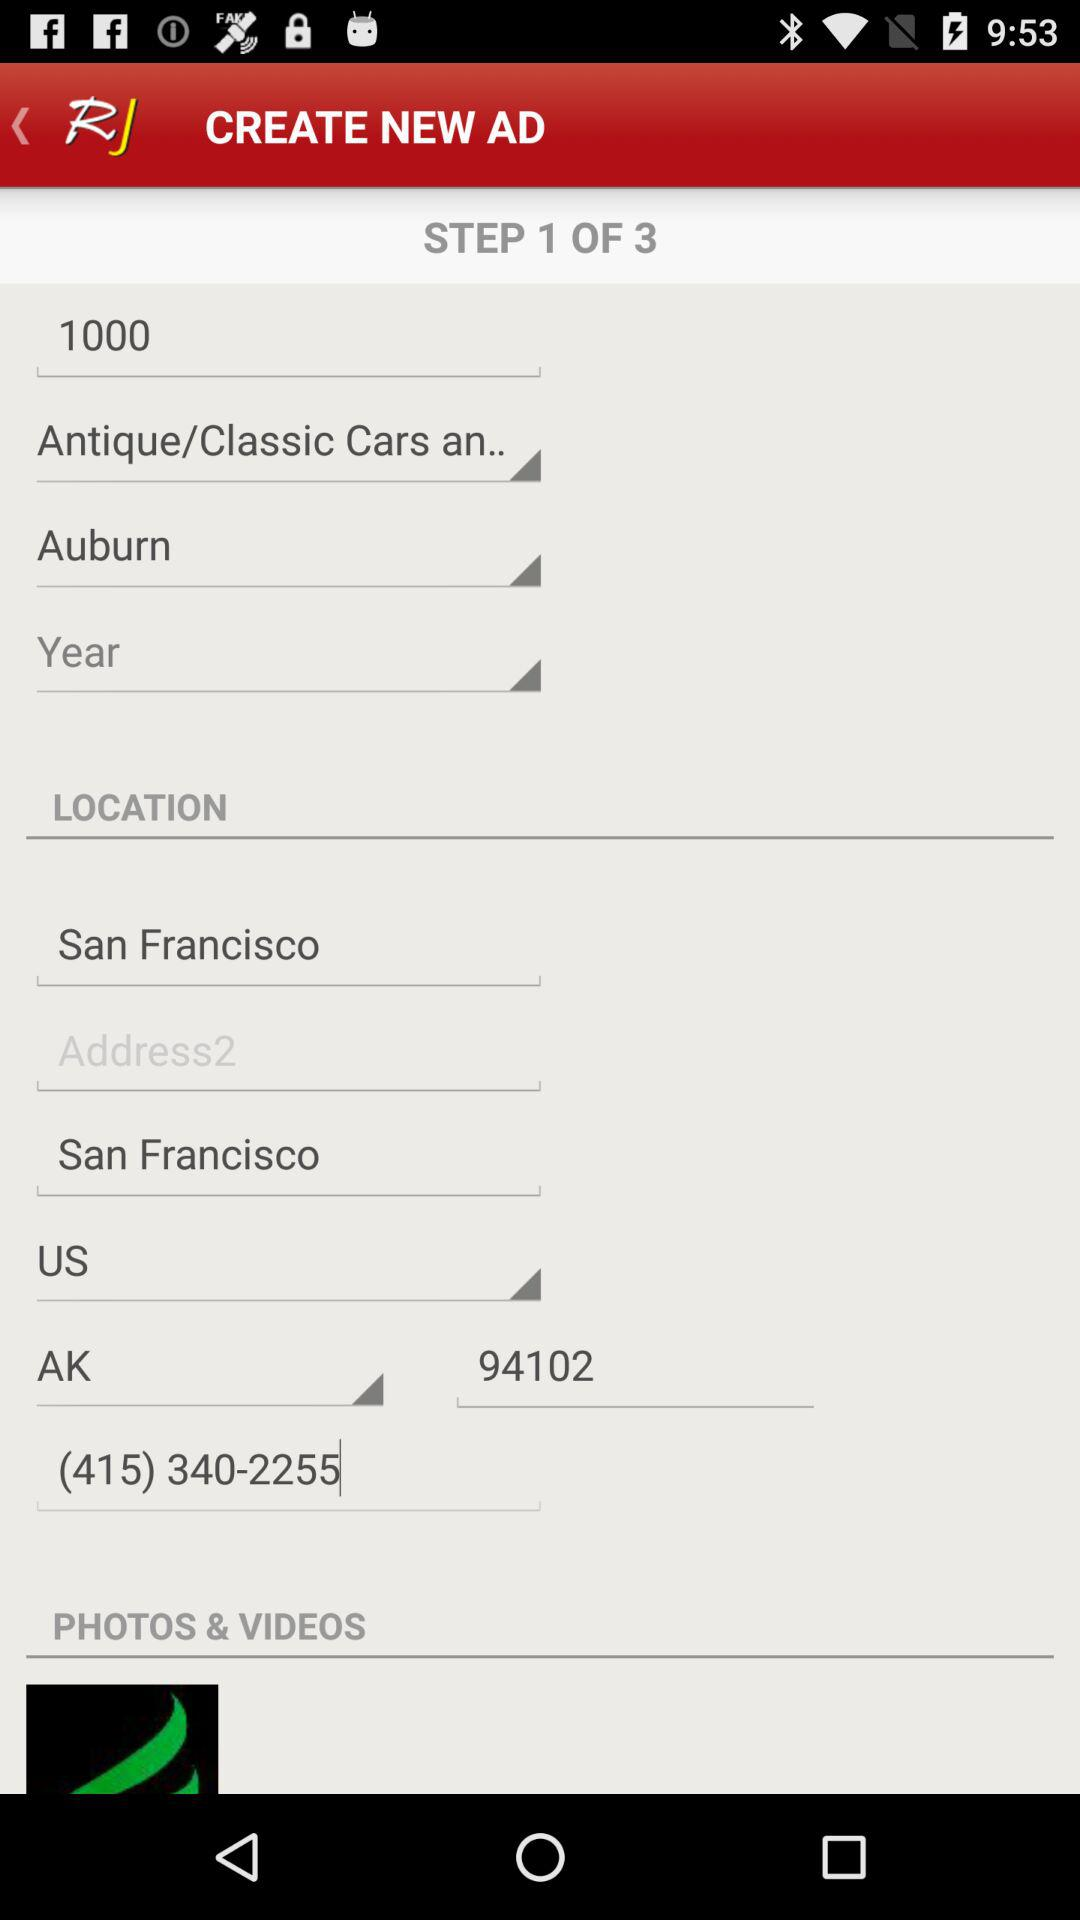How many steps are there in total for creating an advertisement? There are 3 steps. 